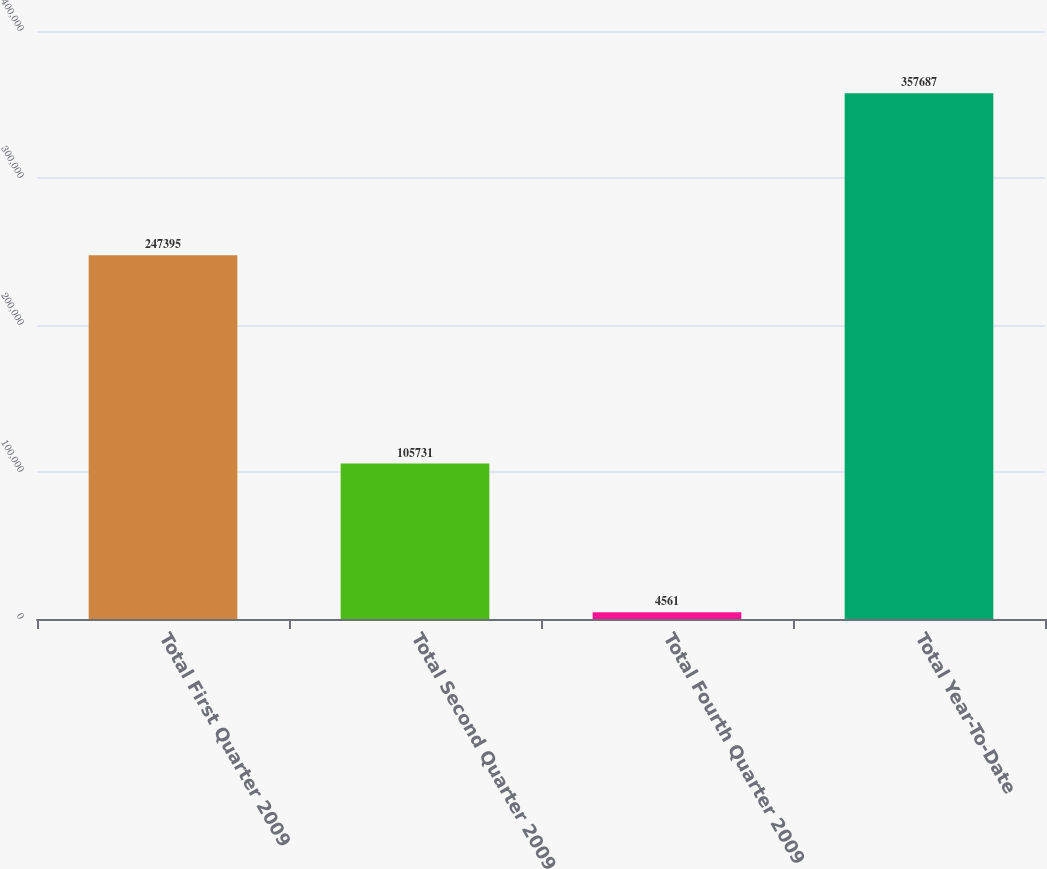Convert chart to OTSL. <chart><loc_0><loc_0><loc_500><loc_500><bar_chart><fcel>Total First Quarter 2009<fcel>Total Second Quarter 2009<fcel>Total Fourth Quarter 2009<fcel>Total Year-To-Date<nl><fcel>247395<fcel>105731<fcel>4561<fcel>357687<nl></chart> 